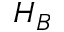Convert formula to latex. <formula><loc_0><loc_0><loc_500><loc_500>H _ { B }</formula> 